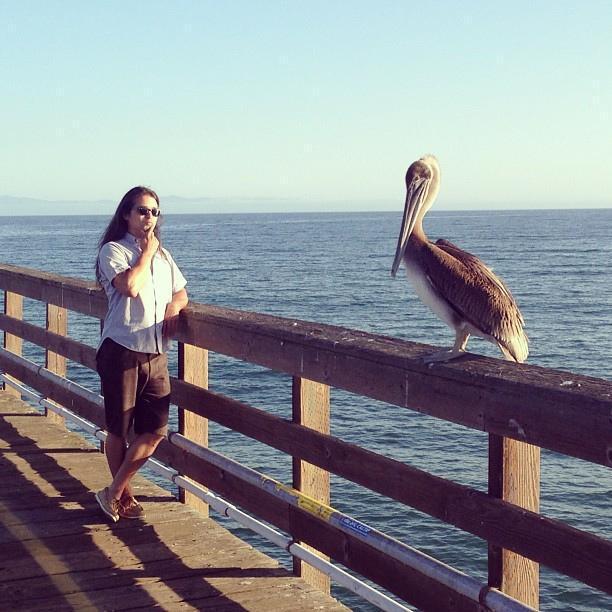How many birds can be seen?
Give a very brief answer. 1. How many giraffe are there?
Give a very brief answer. 0. 